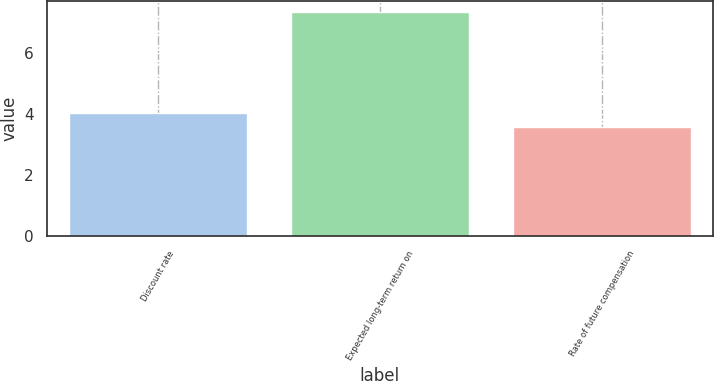Convert chart to OTSL. <chart><loc_0><loc_0><loc_500><loc_500><bar_chart><fcel>Discount rate<fcel>Expected long-term return on<fcel>Rate of future compensation<nl><fcel>4.04<fcel>7.35<fcel>3.58<nl></chart> 